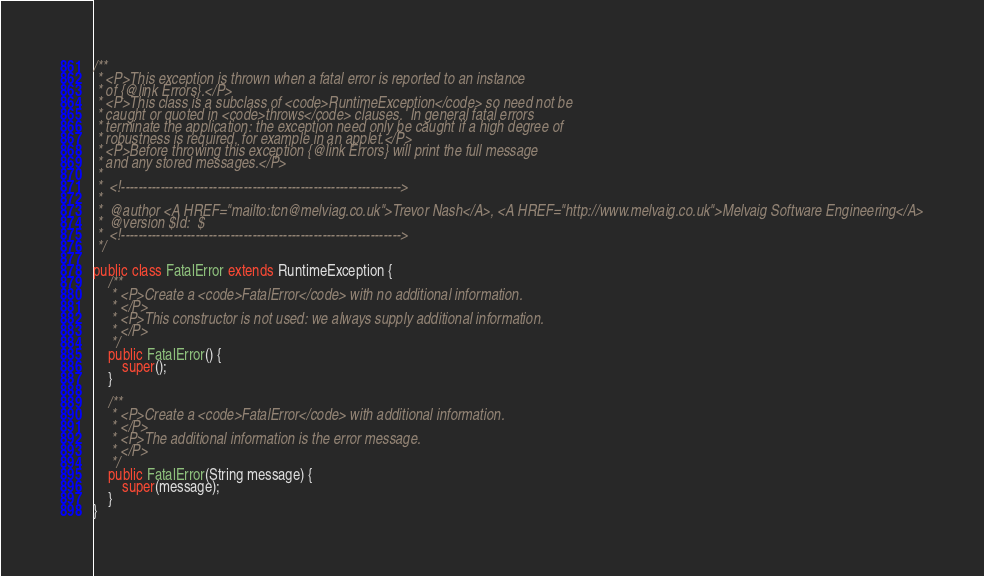Convert code to text. <code><loc_0><loc_0><loc_500><loc_500><_Java_>
/**
 * <P>This exception is thrown when a fatal error is reported to an instance
 * of {@link Errors}.</P>
 * <P>This class is a subclass of <code>RuntimeException</code> so need not be
 * caught or quoted in <code>throws</code> clauses.  In general fatal errors
 * terminate the application: the exception need only be caught if a high degree of
 * robustness is required, for example in an applet.</P>
 * <P>Before throwing this exception {@link Errors} will print the full message
 * and any stored messages.</P>
 *
 *  <!---------------------------------------------------------------->
 * 
 *  @author <A HREF="mailto:tcn@melviag.co.uk">Trevor Nash</A>, <A HREF="http://www.melvaig.co.uk">Melvaig Software Engineering</A>
 *  @version $Id:  $
 *  <!---------------------------------------------------------------->
 */

public class FatalError extends RuntimeException {
    /**
     * <P>Create a <code>FatalError</code> with no additional information.
     * </P>
     * <P>This constructor is not used: we always supply additional information.
     * </P>
     */
    public FatalError() {
        super();
    }

    /**
     * <P>Create a <code>FatalError</code> with additional information.
     * </P>
     * <P>The additional information is the error message.
     * </P>
     */
    public FatalError(String message) {
        super(message);
    }
}
</code> 